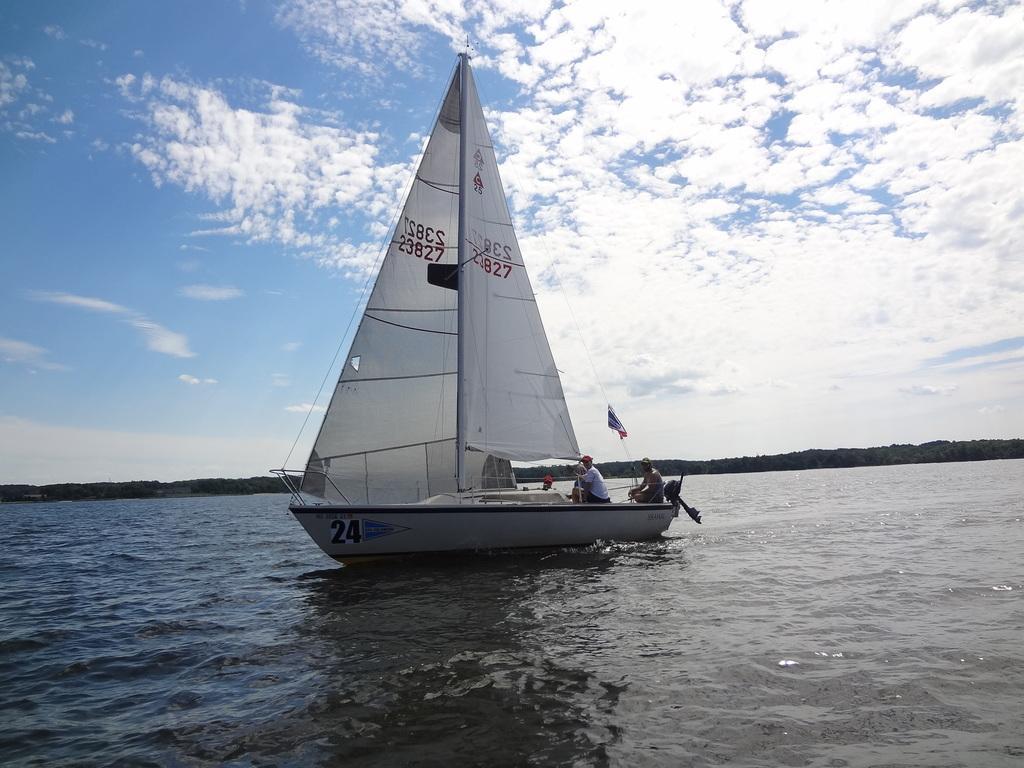Please provide a concise description of this image. In this picture we can see a boat on the water. There are a few people, rods, some numbers on the sails and other objects are visible on this boat. We can see some greenery in the background. Sky is blue in color and cloudy. 